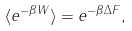Convert formula to latex. <formula><loc_0><loc_0><loc_500><loc_500>\langle e ^ { - \beta W } \rangle = e ^ { - \beta \Delta F } ,</formula> 